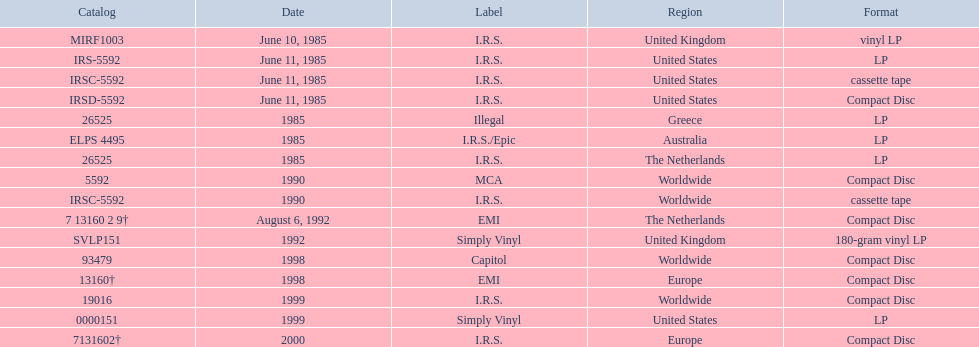In which regions was the fables of the reconstruction album released? United Kingdom, United States, United States, United States, Greece, Australia, The Netherlands, Worldwide, Worldwide, The Netherlands, United Kingdom, Worldwide, Europe, Worldwide, United States, Europe. And what were the release dates for those regions? June 10, 1985, June 11, 1985, June 11, 1985, June 11, 1985, 1985, 1985, 1985, 1990, 1990, August 6, 1992, 1992, 1998, 1998, 1999, 1999, 2000. And which region was listed after greece in 1985? Australia. 